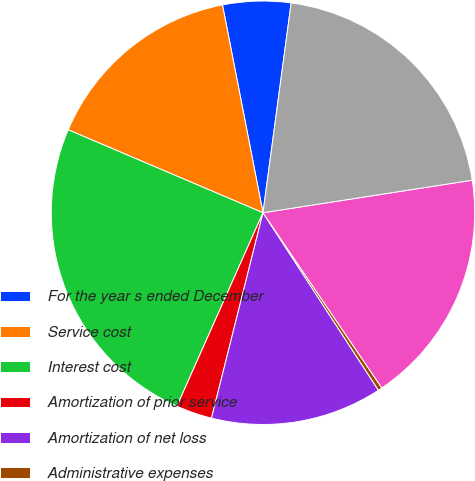<chart> <loc_0><loc_0><loc_500><loc_500><pie_chart><fcel>For the year s ended December<fcel>Service cost<fcel>Interest cost<fcel>Amortization of prior service<fcel>Amortization of net loss<fcel>Administrative expenses<fcel>Net periodic benefit cost<fcel>Total amount reflected in<nl><fcel>5.19%<fcel>15.53%<fcel>24.75%<fcel>2.75%<fcel>13.09%<fcel>0.31%<fcel>17.97%<fcel>20.42%<nl></chart> 